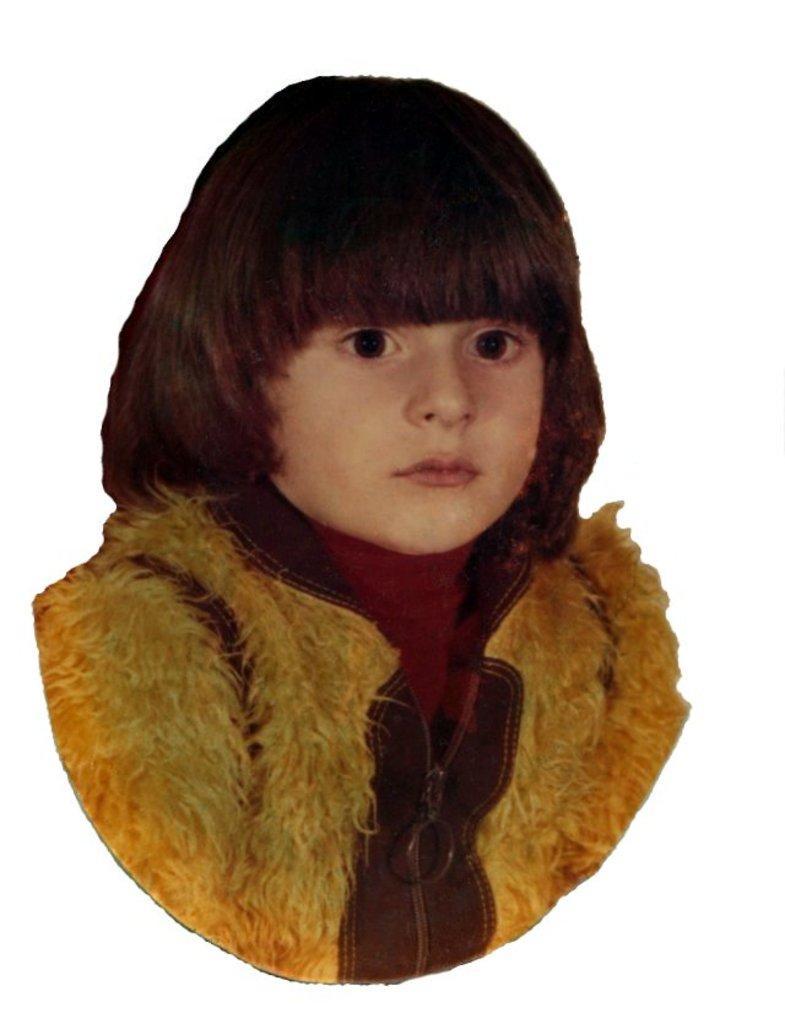How would you summarize this image in a sentence or two? In the image we can see there is a kid and the kid is wearing jacket. The image is the outline of the kid. 